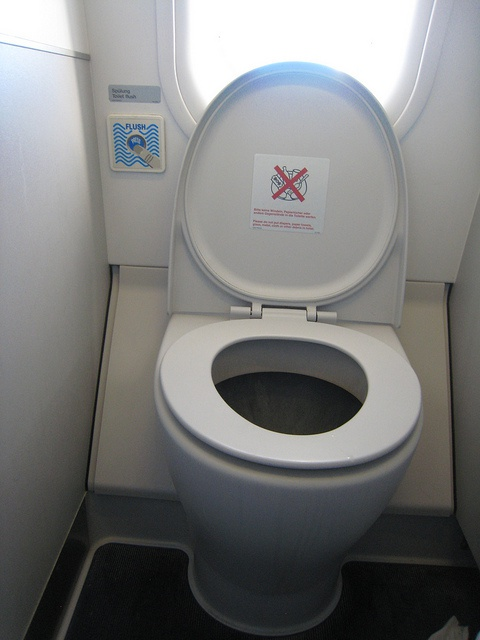Describe the objects in this image and their specific colors. I can see a toilet in white, darkgray, black, and gray tones in this image. 